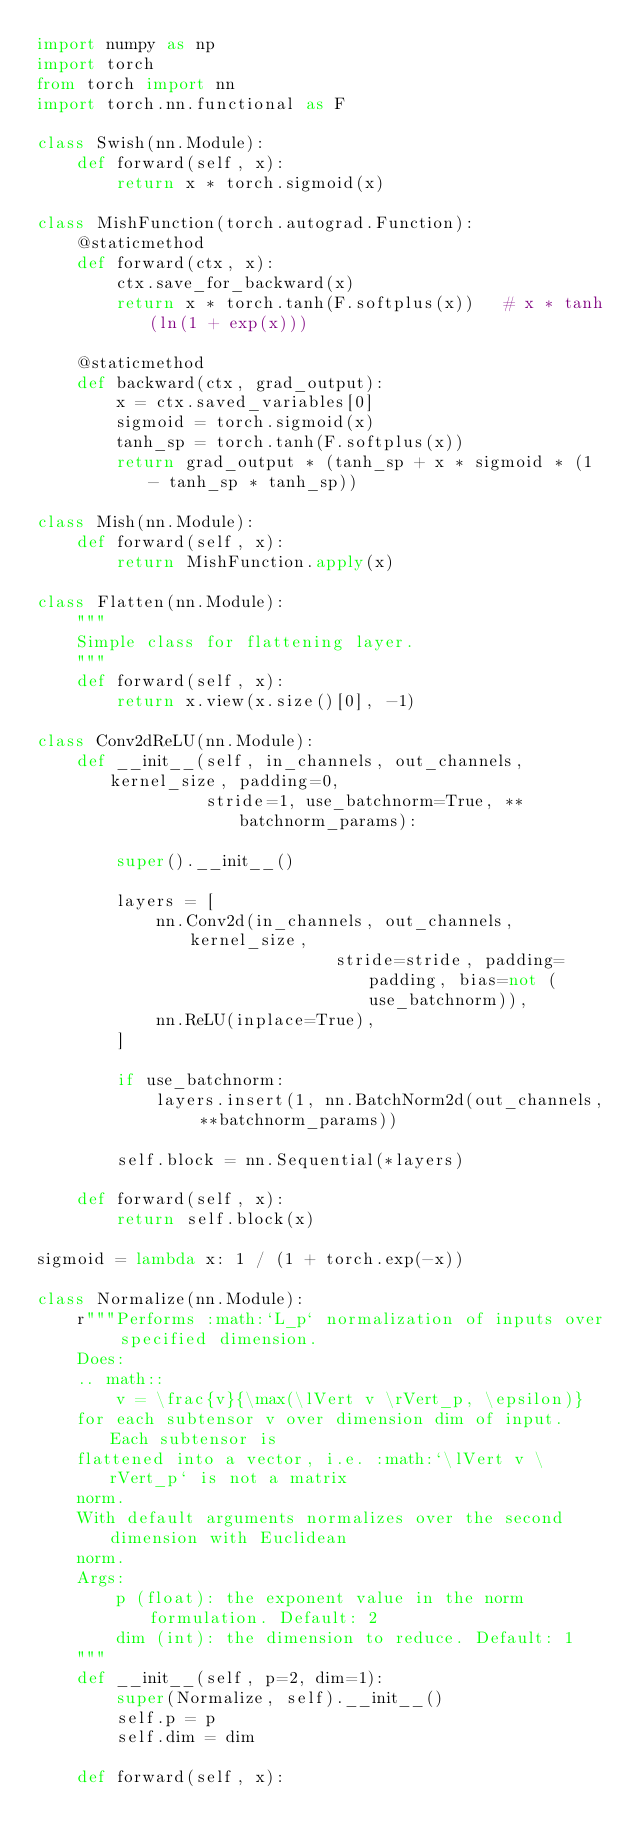<code> <loc_0><loc_0><loc_500><loc_500><_Python_>import numpy as np
import torch
from torch import nn
import torch.nn.functional as F

class Swish(nn.Module):
    def forward(self, x):
        return x * torch.sigmoid(x)
    
class MishFunction(torch.autograd.Function):
    @staticmethod
    def forward(ctx, x):
        ctx.save_for_backward(x)
        return x * torch.tanh(F.softplus(x))   # x * tanh(ln(1 + exp(x)))

    @staticmethod
    def backward(ctx, grad_output):
        x = ctx.saved_variables[0]
        sigmoid = torch.sigmoid(x)
        tanh_sp = torch.tanh(F.softplus(x)) 
        return grad_output * (tanh_sp + x * sigmoid * (1 - tanh_sp * tanh_sp))

class Mish(nn.Module):
    def forward(self, x):
        return MishFunction.apply(x)
    
class Flatten(nn.Module):
    """
    Simple class for flattening layer.
    """
    def forward(self, x):
        return x.view(x.size()[0], -1)
    
class Conv2dReLU(nn.Module):
    def __init__(self, in_channels, out_channels, kernel_size, padding=0,
                 stride=1, use_batchnorm=True, **batchnorm_params):

        super().__init__()

        layers = [
            nn.Conv2d(in_channels, out_channels, kernel_size,
                              stride=stride, padding=padding, bias=not (use_batchnorm)),
            nn.ReLU(inplace=True),
        ]

        if use_batchnorm:
            layers.insert(1, nn.BatchNorm2d(out_channels, **batchnorm_params))

        self.block = nn.Sequential(*layers)

    def forward(self, x):
        return self.block(x)
    
sigmoid = lambda x: 1 / (1 + torch.exp(-x))

class Normalize(nn.Module):
    r"""Performs :math:`L_p` normalization of inputs over specified dimension.
    Does:
    .. math::
        v = \frac{v}{\max(\lVert v \rVert_p, \epsilon)}
    for each subtensor v over dimension dim of input. Each subtensor is
    flattened into a vector, i.e. :math:`\lVert v \rVert_p` is not a matrix
    norm.
    With default arguments normalizes over the second dimension with Euclidean
    norm.
    Args:
        p (float): the exponent value in the norm formulation. Default: 2
        dim (int): the dimension to reduce. Default: 1
    """
    def __init__(self, p=2, dim=1):
        super(Normalize, self).__init__()
        self.p = p
        self.dim = dim

    def forward(self, x):</code> 